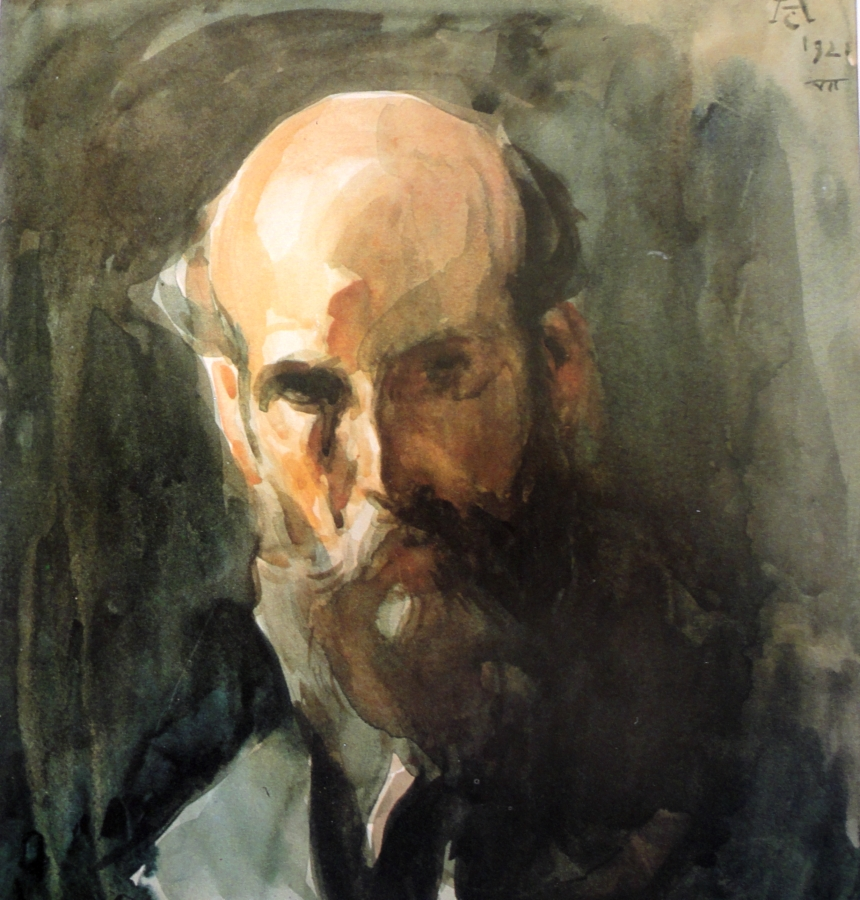How would you describe the use of color in this painting? The use of color in this painting is both subtle and impactful. The artist predominantly utilizes earthy tones like browns and greens, which create a natural and grounded atmosphere. These tones enhance the somber mood of the piece, contributing to its contemplative and reflective nature. The darker background contrasts with the lighter shades of the man’s face, drawing attention to the subject and adding a sense of depth and focus to the overall composition. 